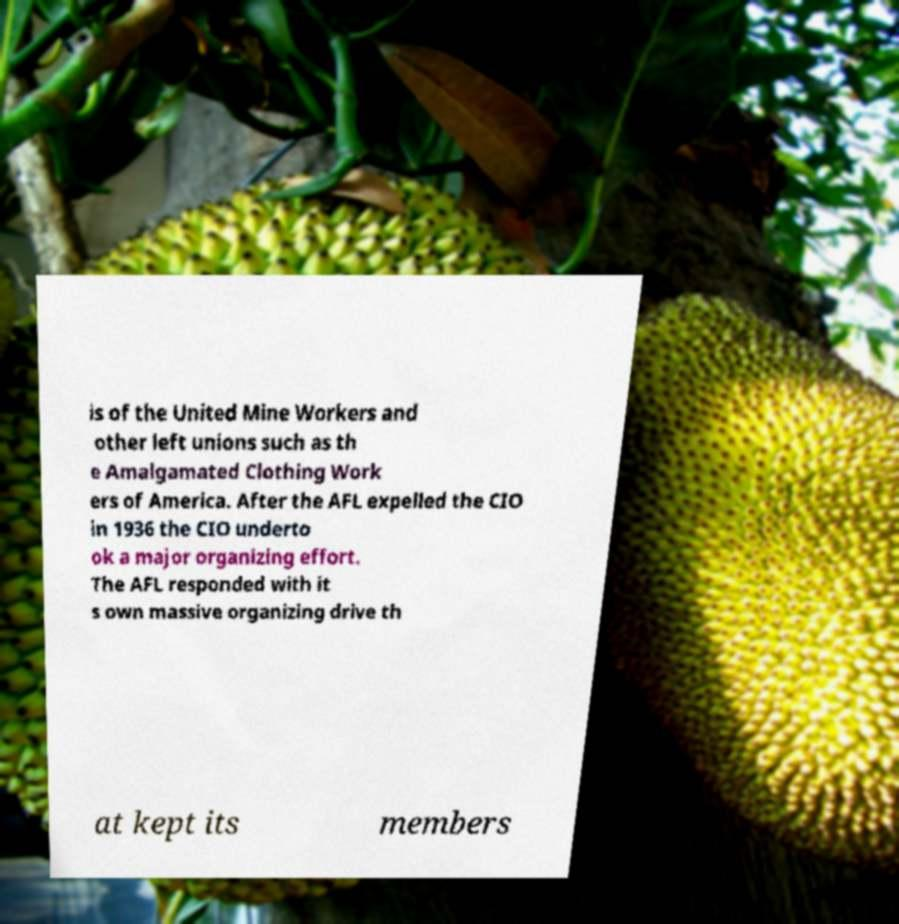There's text embedded in this image that I need extracted. Can you transcribe it verbatim? is of the United Mine Workers and other left unions such as th e Amalgamated Clothing Work ers of America. After the AFL expelled the CIO in 1936 the CIO underto ok a major organizing effort. The AFL responded with it s own massive organizing drive th at kept its members 